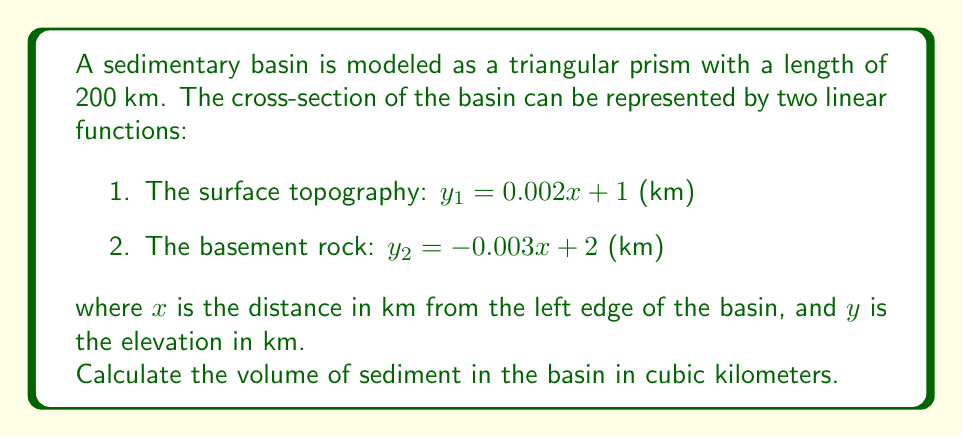Can you answer this question? To solve this problem, we'll follow these steps:

1. Determine the width of the basin:
   The width is where the two functions intersect.
   $$0.002x + 1 = -0.003x + 2$$
   $$0.005x = 1$$
   $$x = 200$$ km

2. Calculate the area of the cross-section:
   The area is the difference between the two functions integrated from 0 to 200.
   
   $$A = \int_0^{200} (y_1 - y_2) dx = \int_0^{200} [(0.002x + 1) - (-0.003x + 2)] dx$$
   $$= \int_0^{200} (0.005x - 1) dx$$
   $$= [0.0025x^2 - x]_0^{200}$$
   $$= (100 - 200) - (0 - 0) = -100$$ km²

3. Calculate the volume:
   The volume is the area of the cross-section multiplied by the length of the basin.
   
   $$V = A \times L = 100 \times 200 = 20,000$$ km³

Therefore, the volume of sediment in the basin is 20,000 cubic kilometers.
Answer: 20,000 km³ 